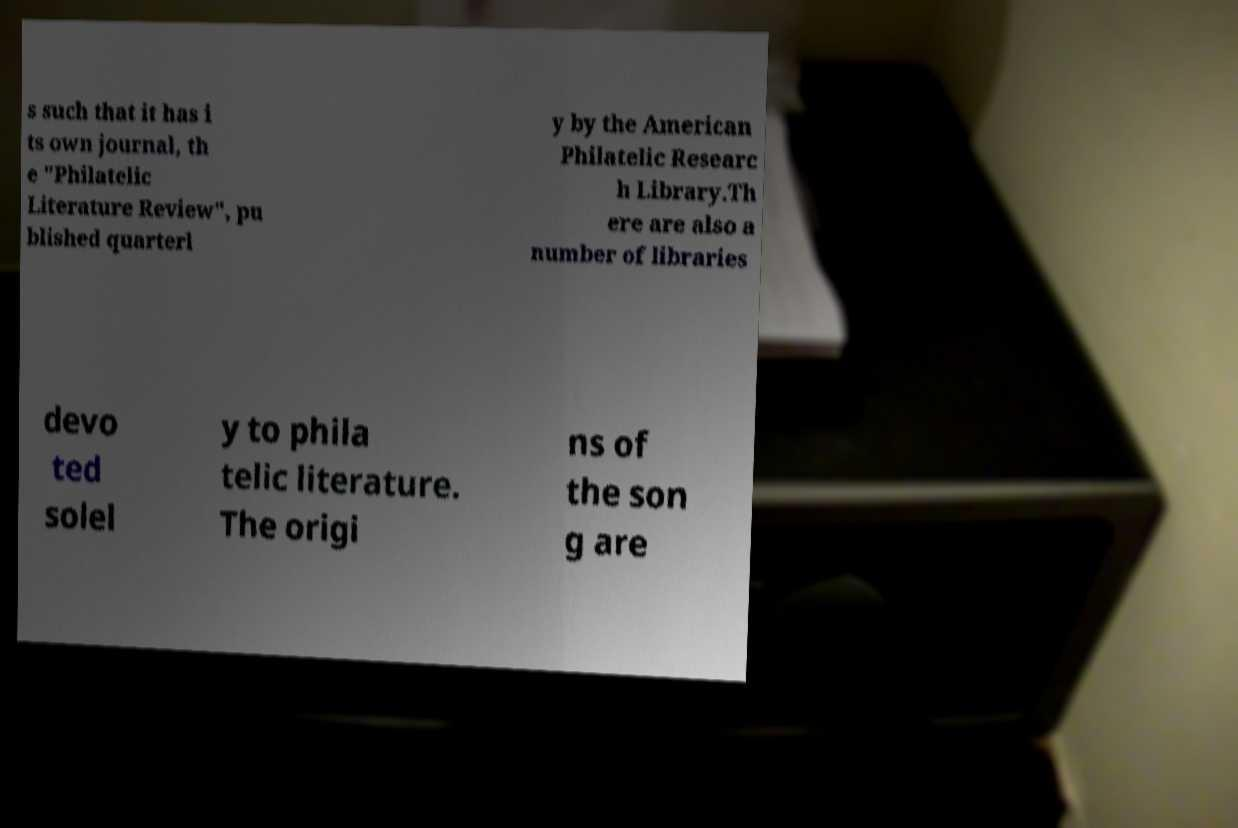I need the written content from this picture converted into text. Can you do that? s such that it has i ts own journal, th e "Philatelic Literature Review", pu blished quarterl y by the American Philatelic Researc h Library.Th ere are also a number of libraries devo ted solel y to phila telic literature. The origi ns of the son g are 